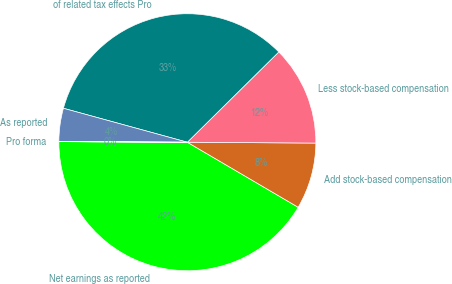<chart> <loc_0><loc_0><loc_500><loc_500><pie_chart><fcel>Net earnings as reported<fcel>Add stock-based compensation<fcel>Less stock-based compensation<fcel>of related tax effects Pro<fcel>As reported<fcel>Pro forma<nl><fcel>41.63%<fcel>8.34%<fcel>12.5%<fcel>33.35%<fcel>4.17%<fcel>0.01%<nl></chart> 